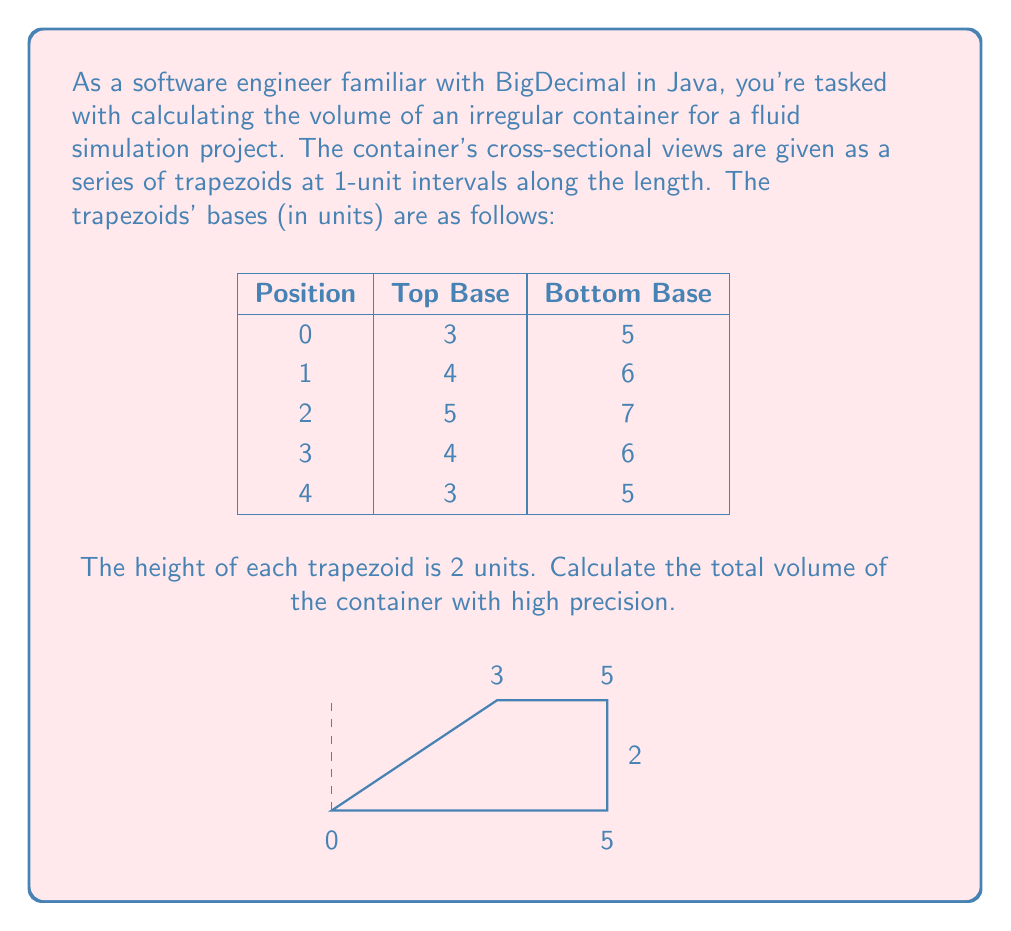Teach me how to tackle this problem. To calculate the volume of this irregular container, we'll use the trapezoidal rule for numerical integration. Here's the step-by-step process:

1) The volume of each section can be calculated using the formula for the volume of a prism with a trapezoidal base:

   $$V_\text{section} = \frac{1}{2}(a + b)h \cdot l$$

   where $a$ and $b$ are the parallel sides of the trapezoid, $h$ is the height of the trapezoid, and $l$ is the length of the section.

2) For each section:
   - $h = 2$ (given)
   - $l = 1$ (1-unit intervals)

3) Calculate the volume of each section:

   Section 0-1: $V_1 = \frac{1}{2}(3 + 5) \cdot 2 \cdot 1 = 8$
   Section 1-2: $V_2 = \frac{1}{2}(4 + 6) \cdot 2 \cdot 1 = 10$
   Section 2-3: $V_3 = \frac{1}{2}(5 + 7) \cdot 2 \cdot 1 = 12$
   Section 3-4: $V_4 = \frac{1}{2}(4 + 6) \cdot 2 \cdot 1 = 10$

4) Sum up all section volumes:

   $$V_\text{total} = V_1 + V_2 + V_3 + V_4 = 8 + 10 + 12 + 10 = 40$$

5) In a real-world scenario with BigDecimal, you would use high-precision arithmetic:

   ```java
   BigDecimal total = BigDecimal.ZERO;
   BigDecimal[] topBases = {new BigDecimal("3"), new BigDecimal("4"), new BigDecimal("5"), new BigDecimal("4")};
   BigDecimal[] bottomBases = {new BigDecimal("5"), new BigDecimal("6"), new BigDecimal("7"), new BigDecimal("6")};
   
   for (int i = 0; i < 4; i++) {
       BigDecimal sectionVolume = topBases[i].add(bottomBases[i])
           .multiply(new BigDecimal("2"))
           .multiply(new BigDecimal("0.5"));
       total = total.add(sectionVolume);
   }
   ```

   This approach ensures high precision in the calculation.
Answer: 40 cubic units 